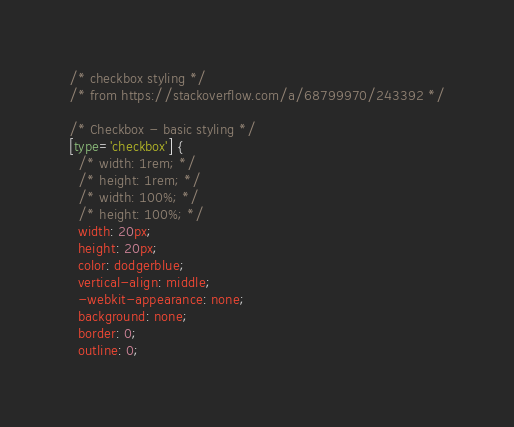<code> <loc_0><loc_0><loc_500><loc_500><_CSS_>/* checkbox styling */
/* from https://stackoverflow.com/a/68799970/243392 */

/* Checkbox - basic styling */
[type='checkbox'] {
  /* width: 1rem; */
  /* height: 1rem; */
  /* width: 100%; */
  /* height: 100%; */
  width: 20px;
  height: 20px;
  color: dodgerblue;
  vertical-align: middle;
  -webkit-appearance: none;
  background: none;
  border: 0;
  outline: 0;</code> 